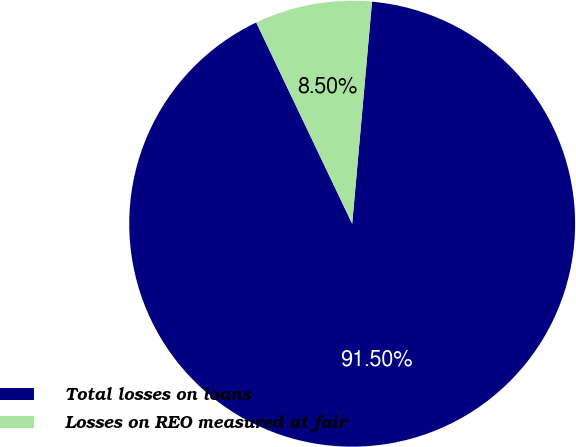Convert chart. <chart><loc_0><loc_0><loc_500><loc_500><pie_chart><fcel>Total losses on loans<fcel>Losses on REO measured at fair<nl><fcel>91.5%<fcel>8.5%<nl></chart> 